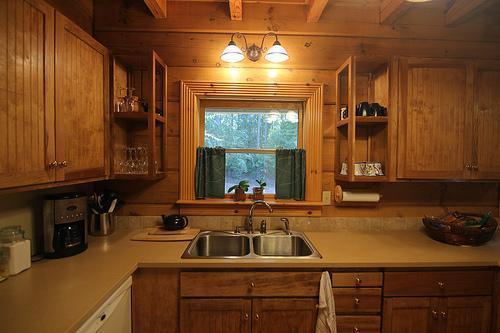How many sinks are in the photo?
Give a very brief answer. 2. How many coffee makers are in the photo?
Give a very brief answer. 1. How many lights are lit on the ceiling?
Give a very brief answer. 2. 